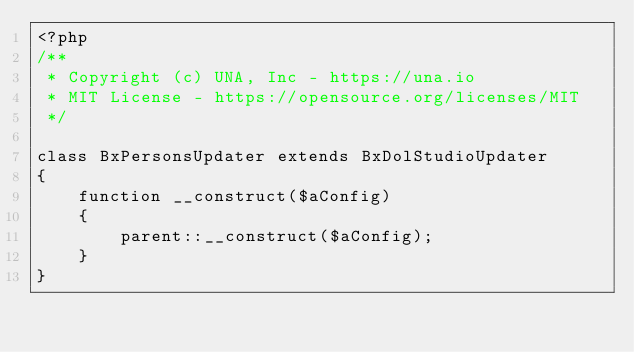Convert code to text. <code><loc_0><loc_0><loc_500><loc_500><_PHP_><?php
/**
 * Copyright (c) UNA, Inc - https://una.io
 * MIT License - https://opensource.org/licenses/MIT
 */

class BxPersonsUpdater extends BxDolStudioUpdater
{
    function __construct($aConfig)
	{
        parent::__construct($aConfig);
    }
}
</code> 